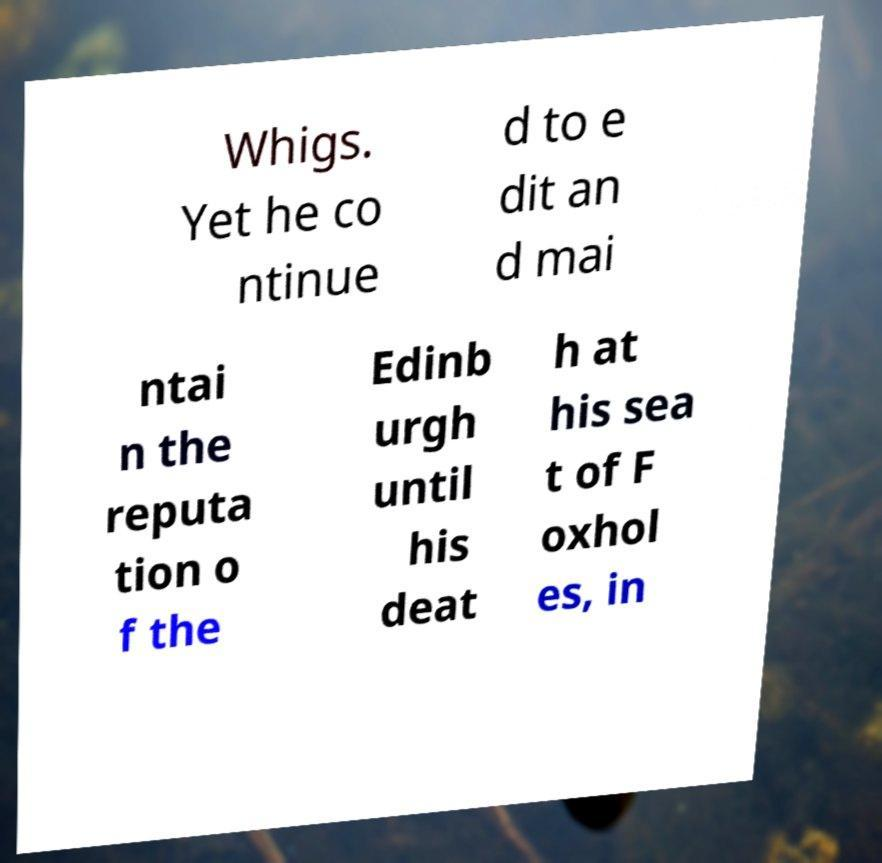What messages or text are displayed in this image? I need them in a readable, typed format. Whigs. Yet he co ntinue d to e dit an d mai ntai n the reputa tion o f the Edinb urgh until his deat h at his sea t of F oxhol es, in 